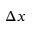Convert formula to latex. <formula><loc_0><loc_0><loc_500><loc_500>\Delta x</formula> 